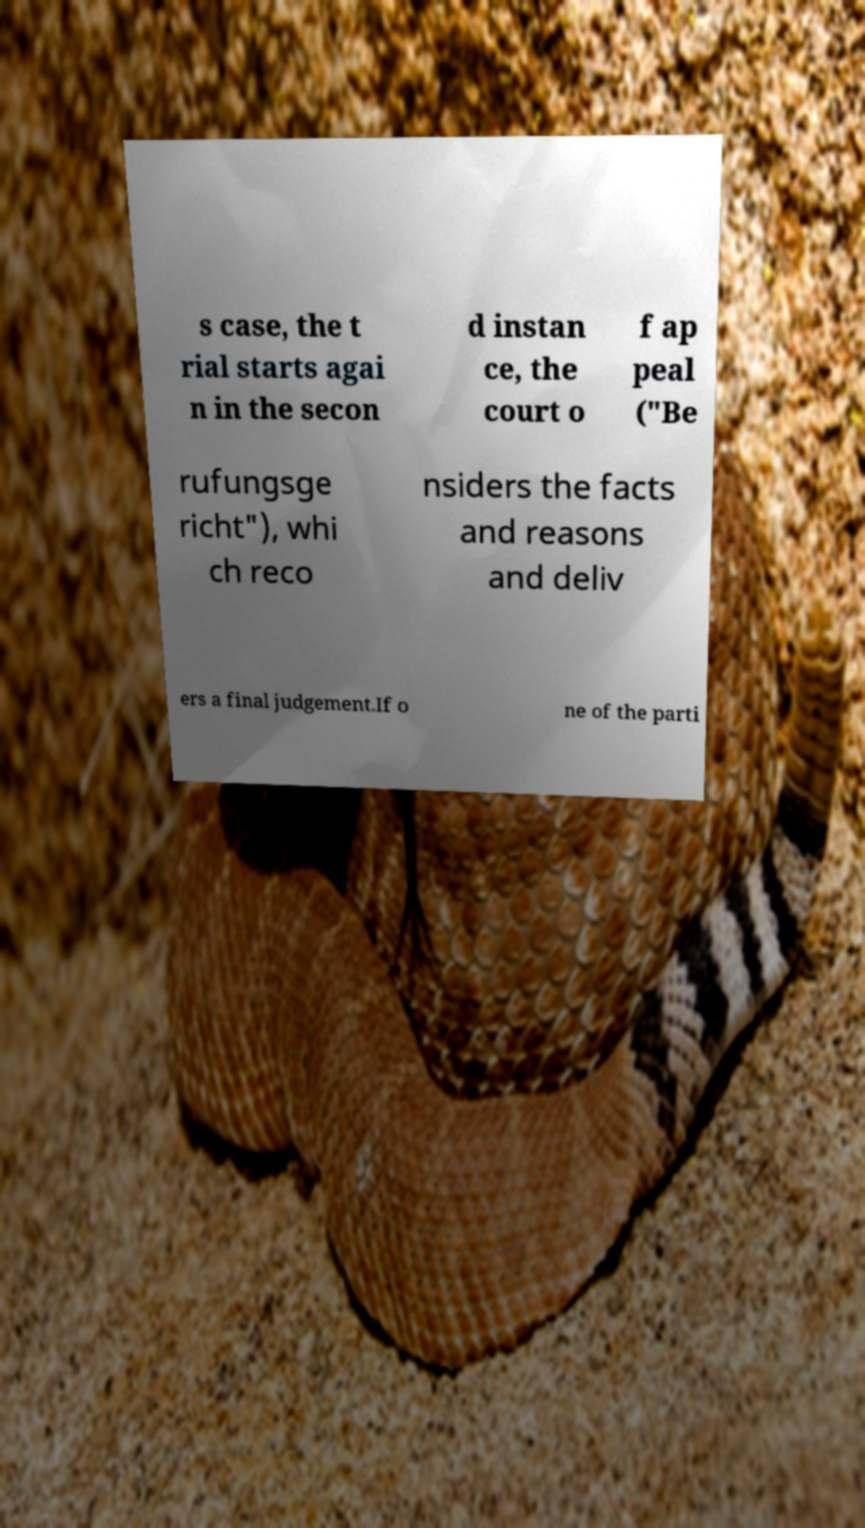I need the written content from this picture converted into text. Can you do that? s case, the t rial starts agai n in the secon d instan ce, the court o f ap peal ("Be rufungsge richt"), whi ch reco nsiders the facts and reasons and deliv ers a final judgement.If o ne of the parti 